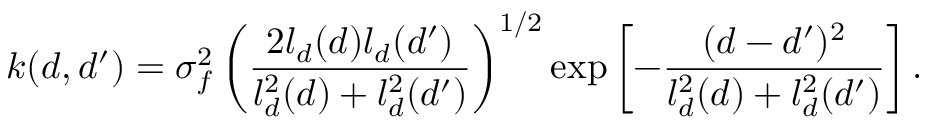<formula> <loc_0><loc_0><loc_500><loc_500>k ( d , d ^ { \prime } ) = \sigma _ { f } ^ { 2 } \left ( \frac { 2 l _ { d } ( d ) l _ { d } ( d ^ { \prime } ) } { l _ { d } ^ { 2 } ( d ) + l _ { d } ^ { 2 } ( d ^ { \prime } ) } \right ) ^ { 1 / 2 } e x p \left [ - \frac { ( d - d ^ { \prime } ) ^ { 2 } } { l _ { d } ^ { 2 } ( d ) + l _ { d } ^ { 2 } ( d ^ { \prime } ) } \right ] .</formula> 